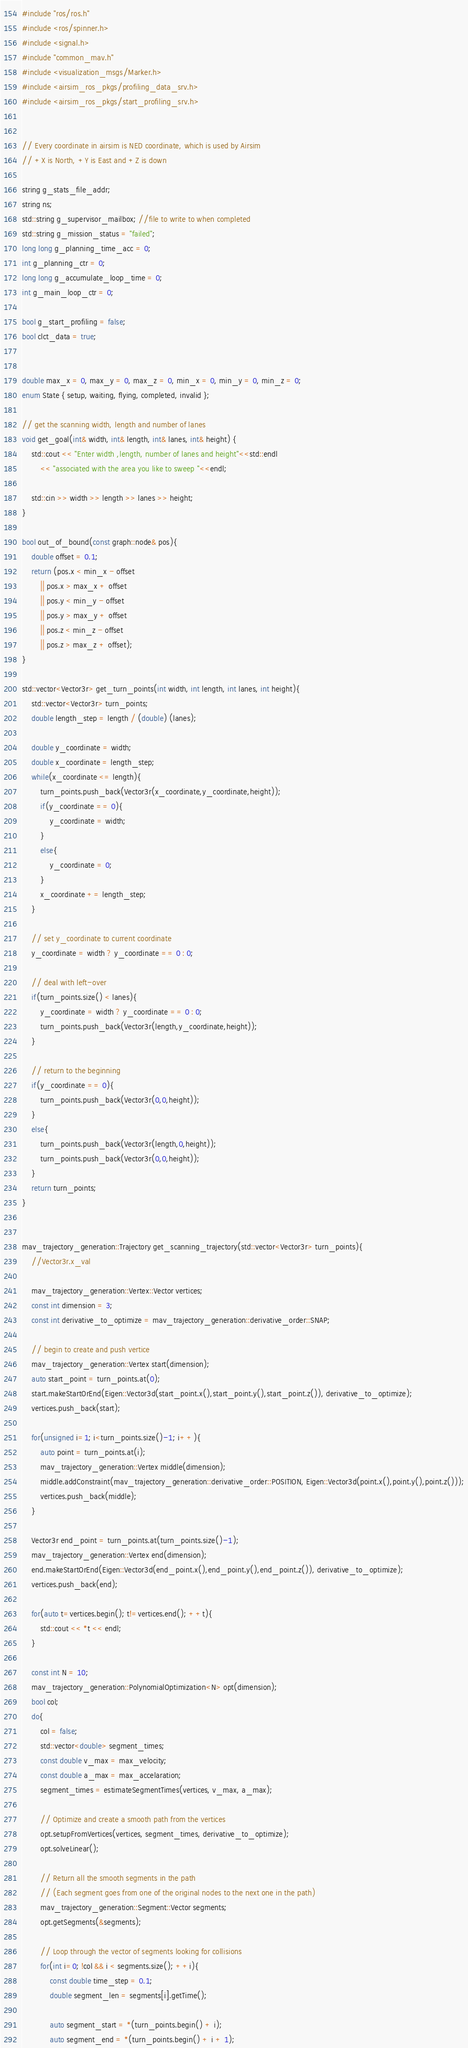<code> <loc_0><loc_0><loc_500><loc_500><_C++_>#include "ros/ros.h"
#include <ros/spinner.h>
#include <signal.h>
#include "common_mav.h"
#include <visualization_msgs/Marker.h>
#include <airsim_ros_pkgs/profiling_data_srv.h>
#include <airsim_ros_pkgs/start_profiling_srv.h>


// Every coordinate in airsim is NED coordinate, which is used by Airsim
// +X is North, +Y is East and +Z is down

string g_stats_file_addr;
string ns;
std::string g_supervisor_mailbox; //file to write to when completed
std::string g_mission_status = "failed";
long long g_planning_time_acc = 0;
int g_planning_ctr = 0;
long long g_accumulate_loop_time = 0;
int g_main_loop_ctr = 0;

bool g_start_profiling = false;
bool clct_data = true;


double max_x = 0, max_y = 0, max_z = 0, min_x = 0, min_y = 0, min_z = 0;
enum State { setup, waiting, flying, completed, invalid };

// get the scanning width, length and number of lanes
void get_goal(int& width, int& length, int& lanes, int& height) {
    std::cout << "Enter width ,length, number of lanes and height"<<std::endl
        << "associated with the area you like to sweep "<<endl;

    std::cin >> width >> length >> lanes >> height;
}

bool out_of_bound(const graph::node& pos){
    double offset = 0.1;
    return (pos.x < min_x - offset
        || pos.x > max_x + offset
        || pos.y < min_y - offset
        || pos.y > max_y + offset
        || pos.z < min_z - offset
        || pos.z > max_z + offset);
}

std::vector<Vector3r> get_turn_points(int width, int length, int lanes, int height){
	std::vector<Vector3r> turn_points;
	double length_step = length / (double) (lanes);

	double y_coordinate = width;
	double x_coordinate = length_step;
	while(x_coordinate <= length){
        turn_points.push_back(Vector3r(x_coordinate,y_coordinate,height));
		if(y_coordinate == 0){
			y_coordinate = width;
		}
		else{
			y_coordinate = 0;
		}
		x_coordinate += length_step;
	}

    // set y_coordinate to current coordinate
    y_coordinate = width ? y_coordinate == 0 : 0;

    // deal with left-over 
    if(turn_points.size() < lanes){
        y_coordinate = width ? y_coordinate == 0 : 0;
        turn_points.push_back(Vector3r(length,y_coordinate,height));
    }

    // return to the beginning
    if(y_coordinate == 0){
        turn_points.push_back(Vector3r(0,0,height));
    }
    else{
        turn_points.push_back(Vector3r(length,0,height));
        turn_points.push_back(Vector3r(0,0,height));
    }
	return turn_points;
}


mav_trajectory_generation::Trajectory get_scanning_trajectory(std::vector<Vector3r> turn_points){
	//Vector3r.x_val
	
	mav_trajectory_generation::Vertex::Vector vertices;
    const int dimension = 3;
    const int derivative_to_optimize = mav_trajectory_generation::derivative_order::SNAP;

    // begin to create and push vertice
    mav_trajectory_generation::Vertex start(dimension);
    auto start_point = turn_points.at(0);
    start.makeStartOrEnd(Eigen::Vector3d(start_point.x(),start_point.y(),start_point.z()), derivative_to_optimize);
    vertices.push_back(start);

    for(unsigned i=1; i<turn_points.size()-1; i++){
    	auto point = turn_points.at(i);
    	mav_trajectory_generation::Vertex middle(dimension);
    	middle.addConstraint(mav_trajectory_generation::derivative_order::POSITION, Eigen::Vector3d(point.x(),point.y(),point.z()));
        vertices.push_back(middle);
    }

    Vector3r end_point = turn_points.at(turn_points.size()-1);
    mav_trajectory_generation::Vertex end(dimension);
    end.makeStartOrEnd(Eigen::Vector3d(end_point.x(),end_point.y(),end_point.z()), derivative_to_optimize);
    vertices.push_back(end);

    for(auto t=vertices.begin(); t!=vertices.end(); ++t){
        std::cout << *t << endl;
    }

    const int N = 10;
    mav_trajectory_generation::PolynomialOptimization<N> opt(dimension);
    bool col;
    do{
        col = false;
        std::vector<double> segment_times;
        const double v_max = max_velocity;
        const double a_max = max_accelaration;
        segment_times = estimateSegmentTimes(vertices, v_max, a_max);

        // Optimize and create a smooth path from the vertices
        opt.setupFromVertices(vertices, segment_times, derivative_to_optimize);
        opt.solveLinear();

        // Return all the smooth segments in the path
        // (Each segment goes from one of the original nodes to the next one in the path)
        mav_trajectory_generation::Segment::Vector segments;
        opt.getSegments(&segments);

        // Loop through the vector of segments looking for collisions
        for(int i=0; !col && i < segments.size(); ++i){
            const double time_step = 0.1;
            double segment_len = segments[i].getTime();

            auto segment_start = *(turn_points.begin() + i);
            auto segment_end = *(turn_points.begin() + i + 1);
</code> 